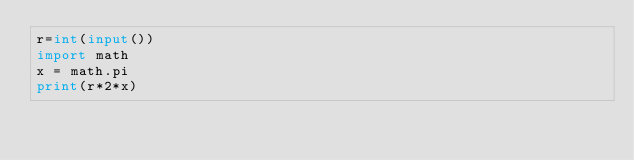<code> <loc_0><loc_0><loc_500><loc_500><_Python_>r=int(input())
import math
x = math.pi
print(r*2*x)</code> 